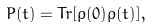<formula> <loc_0><loc_0><loc_500><loc_500>P ( t ) = T r [ \rho ( 0 ) \rho ( t ) ] ,</formula> 